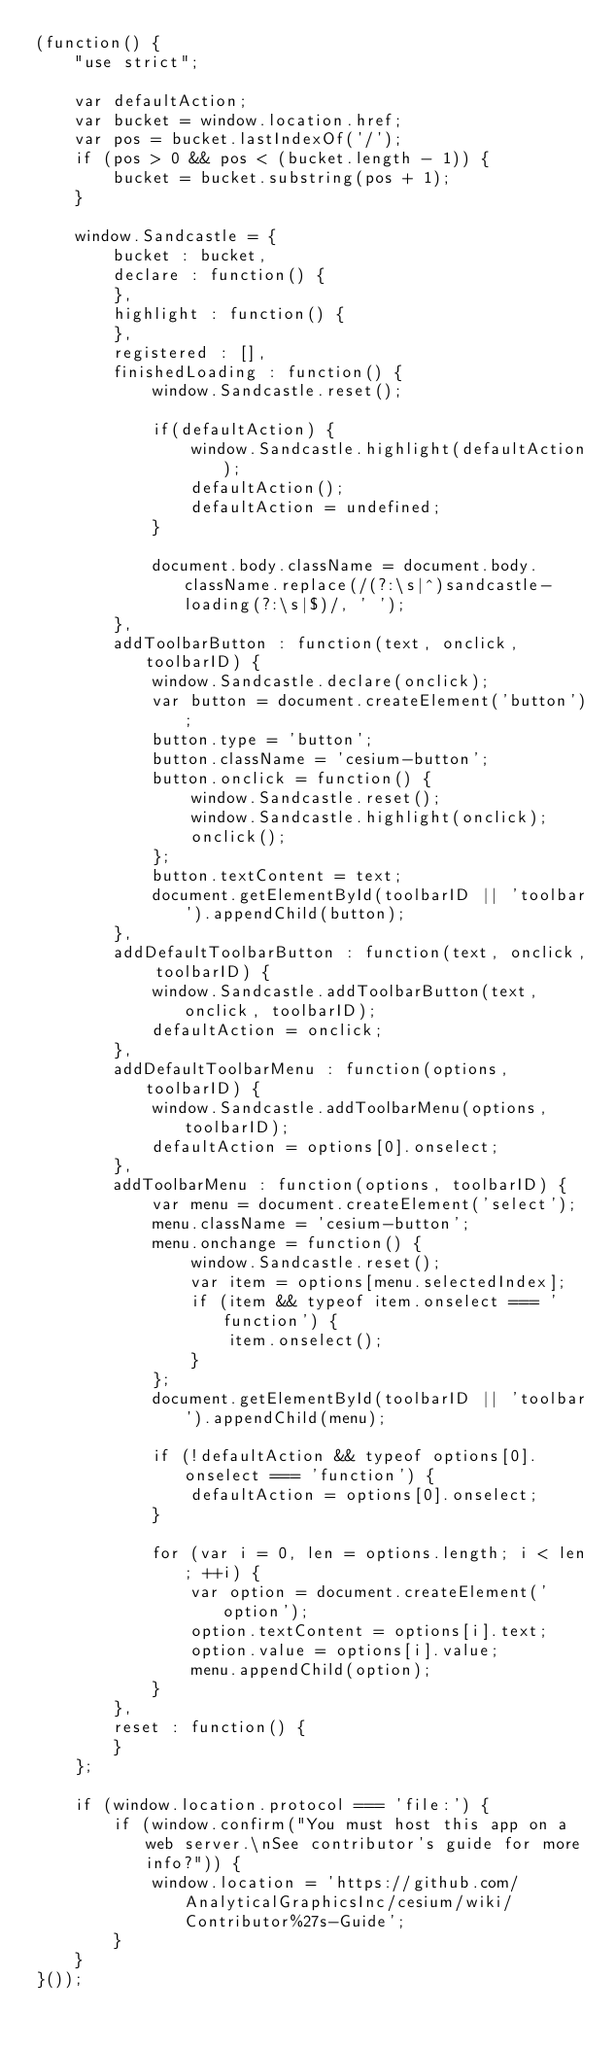Convert code to text. <code><loc_0><loc_0><loc_500><loc_500><_JavaScript_>(function() {
    "use strict";

    var defaultAction;
    var bucket = window.location.href;
    var pos = bucket.lastIndexOf('/');
    if (pos > 0 && pos < (bucket.length - 1)) {
        bucket = bucket.substring(pos + 1);
    }

    window.Sandcastle = {
        bucket : bucket,
        declare : function() {
        },
        highlight : function() {
        },
        registered : [],
        finishedLoading : function() {
            window.Sandcastle.reset();

            if(defaultAction) {
                window.Sandcastle.highlight(defaultAction);
                defaultAction();
                defaultAction = undefined;
            }

            document.body.className = document.body.className.replace(/(?:\s|^)sandcastle-loading(?:\s|$)/, ' ');
        },
        addToolbarButton : function(text, onclick, toolbarID) {
            window.Sandcastle.declare(onclick);
            var button = document.createElement('button');
            button.type = 'button';
            button.className = 'cesium-button';
            button.onclick = function() {
                window.Sandcastle.reset();
                window.Sandcastle.highlight(onclick);
                onclick();
            };
            button.textContent = text;
            document.getElementById(toolbarID || 'toolbar').appendChild(button);
        },
        addDefaultToolbarButton : function(text, onclick, toolbarID) {
            window.Sandcastle.addToolbarButton(text, onclick, toolbarID);
            defaultAction = onclick;
        },
        addDefaultToolbarMenu : function(options, toolbarID) {
            window.Sandcastle.addToolbarMenu(options, toolbarID);
            defaultAction = options[0].onselect;
        },
        addToolbarMenu : function(options, toolbarID) {
            var menu = document.createElement('select');
            menu.className = 'cesium-button';
            menu.onchange = function() {
                window.Sandcastle.reset();
                var item = options[menu.selectedIndex];
                if (item && typeof item.onselect === 'function') {
                    item.onselect();
                }
            };
            document.getElementById(toolbarID || 'toolbar').appendChild(menu);

            if (!defaultAction && typeof options[0].onselect === 'function') {
                defaultAction = options[0].onselect;
            }

            for (var i = 0, len = options.length; i < len; ++i) {
                var option = document.createElement('option');
                option.textContent = options[i].text;
                option.value = options[i].value;
                menu.appendChild(option);
            }
        },
        reset : function() {
        }
    };

    if (window.location.protocol === 'file:') {
        if (window.confirm("You must host this app on a web server.\nSee contributor's guide for more info?")) {
            window.location = 'https://github.com/AnalyticalGraphicsInc/cesium/wiki/Contributor%27s-Guide';
        }
    }
}());
</code> 